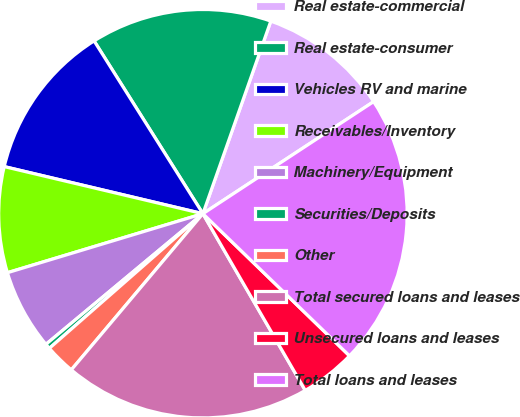<chart> <loc_0><loc_0><loc_500><loc_500><pie_chart><fcel>Real estate-commercial<fcel>Real estate-consumer<fcel>Vehicles RV and marine<fcel>Receivables/Inventory<fcel>Machinery/Equipment<fcel>Securities/Deposits<fcel>Other<fcel>Total secured loans and leases<fcel>Unsecured loans and leases<fcel>Total loans and leases<nl><fcel>10.36%<fcel>14.34%<fcel>12.35%<fcel>8.37%<fcel>6.38%<fcel>0.41%<fcel>2.4%<fcel>19.5%<fcel>4.39%<fcel>21.5%<nl></chart> 